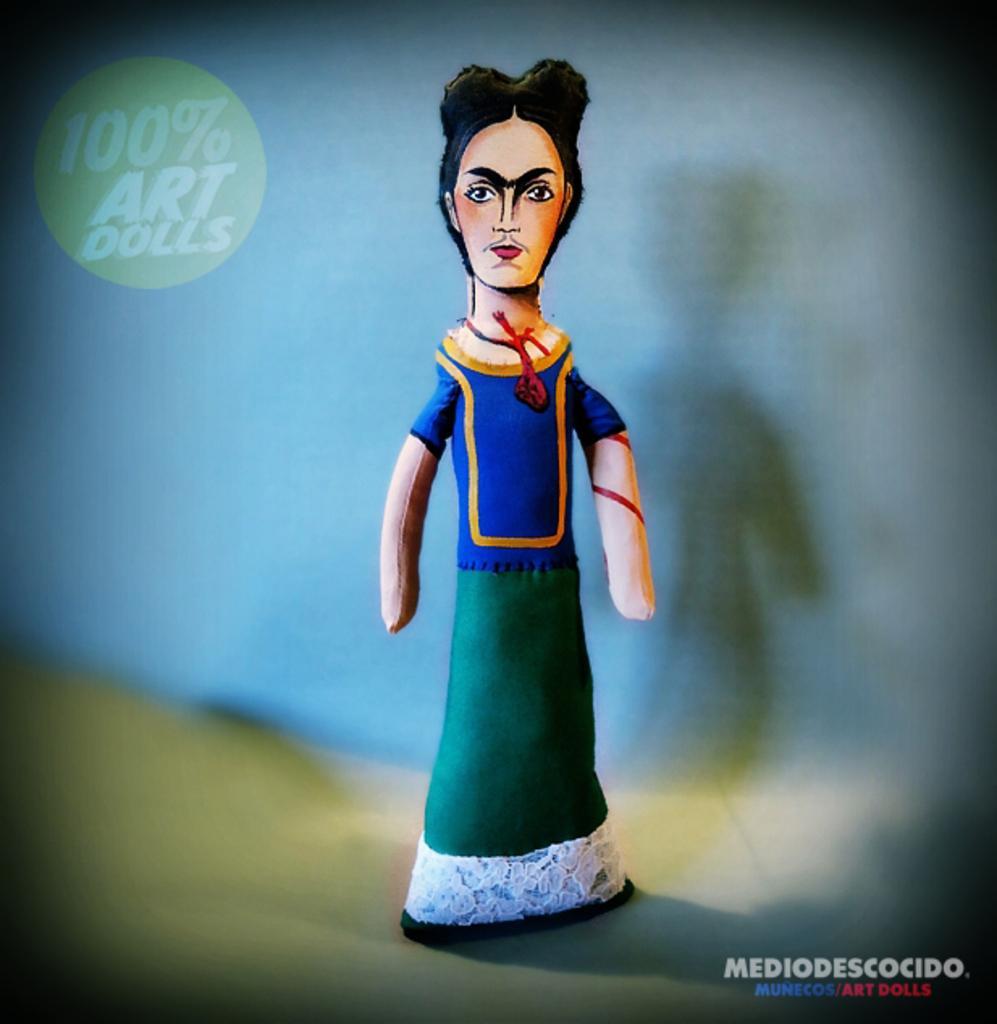Can you describe this image briefly? In this image we can see a toy on the surface. This part of the image is slightly blurred. Here we can see the logo on the top left side of the image. Here can see the watermark on the bottom right side of the image. 